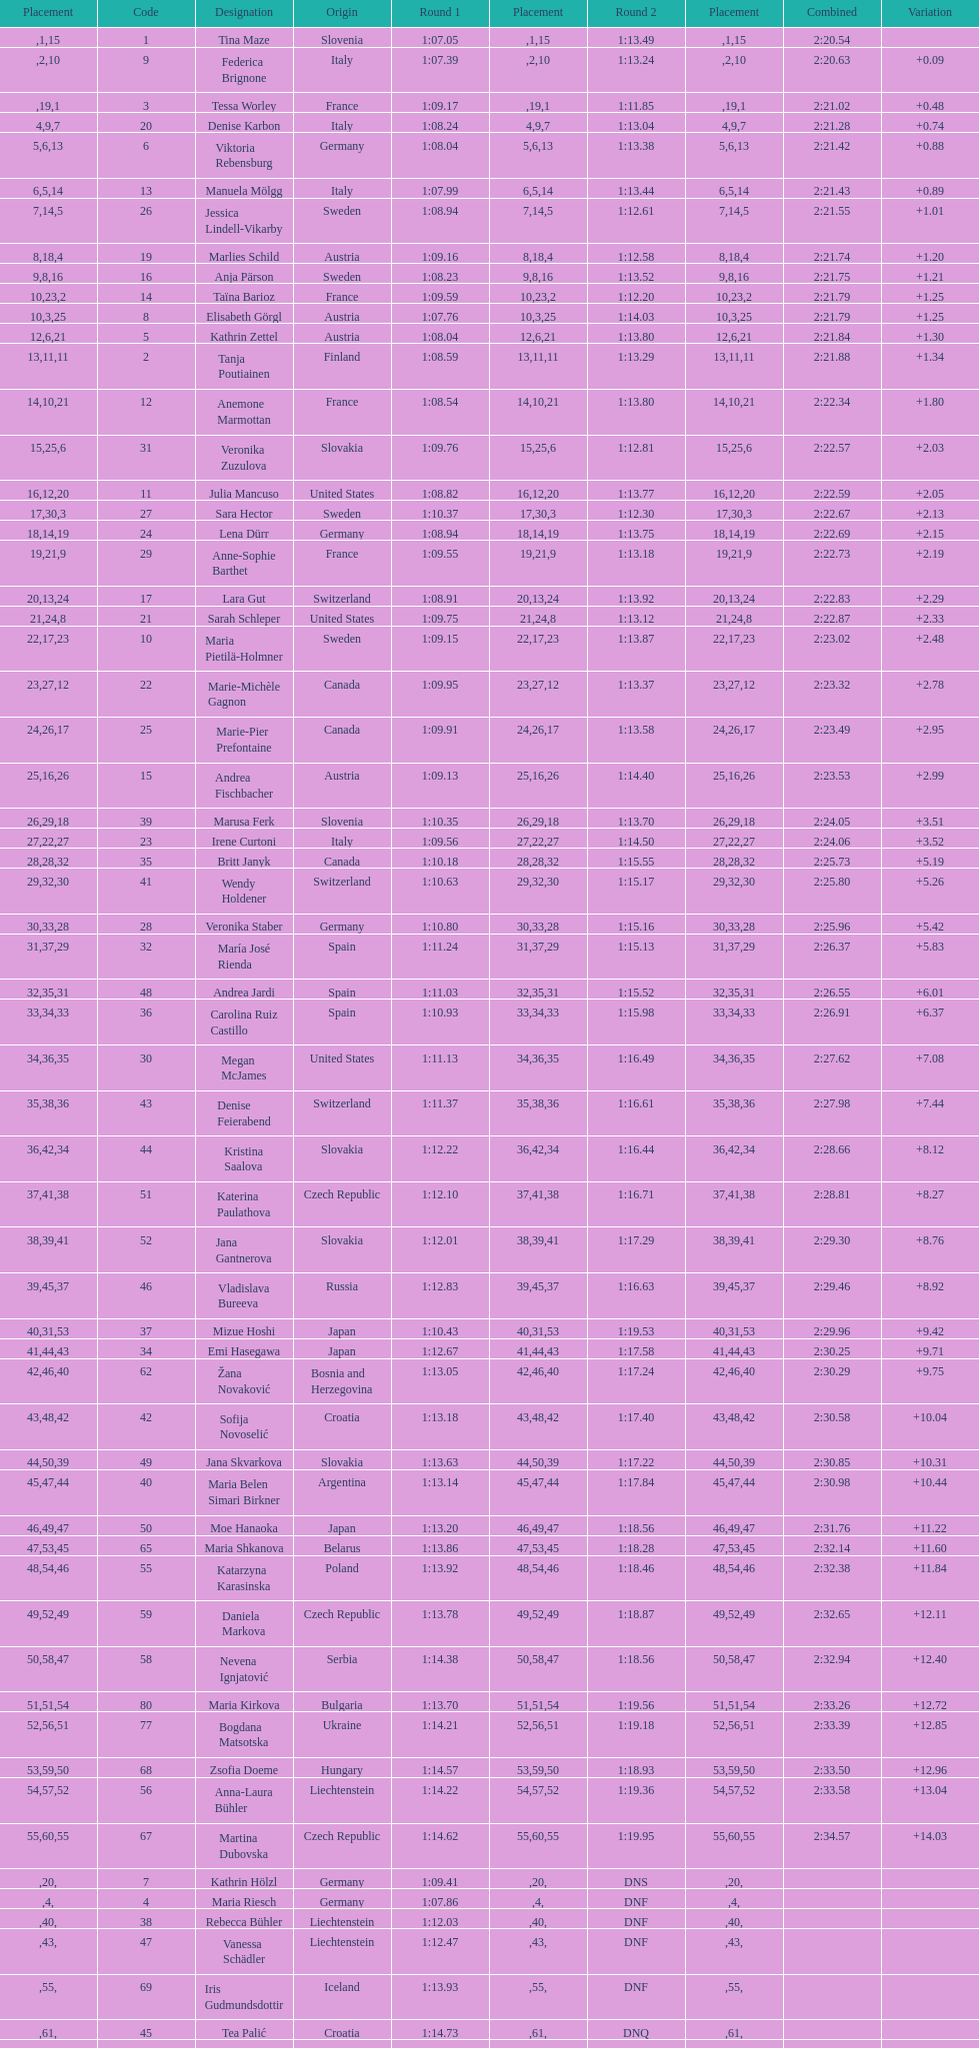How many athletes had the same rank for both run 1 and run 2? 1. 